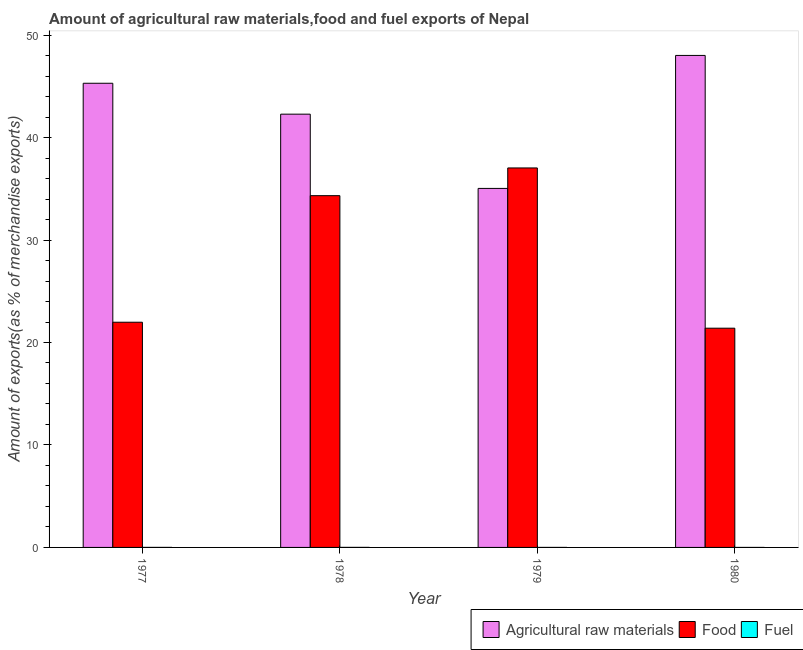How many groups of bars are there?
Your response must be concise. 4. Are the number of bars per tick equal to the number of legend labels?
Your answer should be compact. Yes. How many bars are there on the 3rd tick from the right?
Offer a terse response. 3. What is the label of the 2nd group of bars from the left?
Offer a very short reply. 1978. In how many cases, is the number of bars for a given year not equal to the number of legend labels?
Make the answer very short. 0. What is the percentage of food exports in 1977?
Offer a terse response. 21.98. Across all years, what is the maximum percentage of food exports?
Offer a very short reply. 37.03. Across all years, what is the minimum percentage of fuel exports?
Keep it short and to the point. 4.5184108995034e-5. In which year was the percentage of fuel exports maximum?
Provide a short and direct response. 1978. In which year was the percentage of raw materials exports minimum?
Keep it short and to the point. 1979. What is the total percentage of food exports in the graph?
Keep it short and to the point. 114.74. What is the difference between the percentage of food exports in 1977 and that in 1979?
Your answer should be very brief. -15.06. What is the difference between the percentage of fuel exports in 1978 and the percentage of raw materials exports in 1979?
Keep it short and to the point. 0. What is the average percentage of food exports per year?
Your answer should be compact. 28.68. In the year 1979, what is the difference between the percentage of food exports and percentage of fuel exports?
Give a very brief answer. 0. In how many years, is the percentage of raw materials exports greater than 16 %?
Keep it short and to the point. 4. What is the ratio of the percentage of fuel exports in 1977 to that in 1980?
Ensure brevity in your answer.  47.85. Is the percentage of food exports in 1977 less than that in 1979?
Provide a succinct answer. Yes. What is the difference between the highest and the second highest percentage of fuel exports?
Provide a succinct answer. 0. What is the difference between the highest and the lowest percentage of fuel exports?
Your answer should be very brief. 0. What does the 1st bar from the left in 1977 represents?
Your answer should be very brief. Agricultural raw materials. What does the 3rd bar from the right in 1979 represents?
Keep it short and to the point. Agricultural raw materials. How many bars are there?
Offer a very short reply. 12. Are the values on the major ticks of Y-axis written in scientific E-notation?
Offer a terse response. No. Where does the legend appear in the graph?
Your answer should be compact. Bottom right. What is the title of the graph?
Offer a terse response. Amount of agricultural raw materials,food and fuel exports of Nepal. What is the label or title of the Y-axis?
Your answer should be very brief. Amount of exports(as % of merchandise exports). What is the Amount of exports(as % of merchandise exports) of Agricultural raw materials in 1977?
Give a very brief answer. 45.3. What is the Amount of exports(as % of merchandise exports) in Food in 1977?
Your answer should be very brief. 21.98. What is the Amount of exports(as % of merchandise exports) in Fuel in 1977?
Provide a short and direct response. 0. What is the Amount of exports(as % of merchandise exports) of Agricultural raw materials in 1978?
Your answer should be very brief. 42.28. What is the Amount of exports(as % of merchandise exports) in Food in 1978?
Give a very brief answer. 34.33. What is the Amount of exports(as % of merchandise exports) in Fuel in 1978?
Your answer should be very brief. 0. What is the Amount of exports(as % of merchandise exports) in Agricultural raw materials in 1979?
Ensure brevity in your answer.  35.04. What is the Amount of exports(as % of merchandise exports) of Food in 1979?
Your answer should be compact. 37.03. What is the Amount of exports(as % of merchandise exports) of Fuel in 1979?
Give a very brief answer. 0. What is the Amount of exports(as % of merchandise exports) of Agricultural raw materials in 1980?
Make the answer very short. 48.02. What is the Amount of exports(as % of merchandise exports) of Food in 1980?
Offer a very short reply. 21.4. What is the Amount of exports(as % of merchandise exports) in Fuel in 1980?
Your response must be concise. 4.5184108995034e-5. Across all years, what is the maximum Amount of exports(as % of merchandise exports) of Agricultural raw materials?
Provide a succinct answer. 48.02. Across all years, what is the maximum Amount of exports(as % of merchandise exports) of Food?
Make the answer very short. 37.03. Across all years, what is the maximum Amount of exports(as % of merchandise exports) of Fuel?
Your answer should be very brief. 0. Across all years, what is the minimum Amount of exports(as % of merchandise exports) of Agricultural raw materials?
Provide a succinct answer. 35.04. Across all years, what is the minimum Amount of exports(as % of merchandise exports) in Food?
Provide a short and direct response. 21.4. Across all years, what is the minimum Amount of exports(as % of merchandise exports) of Fuel?
Give a very brief answer. 4.5184108995034e-5. What is the total Amount of exports(as % of merchandise exports) in Agricultural raw materials in the graph?
Your response must be concise. 170.64. What is the total Amount of exports(as % of merchandise exports) of Food in the graph?
Ensure brevity in your answer.  114.74. What is the total Amount of exports(as % of merchandise exports) of Fuel in the graph?
Provide a succinct answer. 0.01. What is the difference between the Amount of exports(as % of merchandise exports) in Agricultural raw materials in 1977 and that in 1978?
Your response must be concise. 3.02. What is the difference between the Amount of exports(as % of merchandise exports) in Food in 1977 and that in 1978?
Give a very brief answer. -12.35. What is the difference between the Amount of exports(as % of merchandise exports) in Fuel in 1977 and that in 1978?
Your answer should be very brief. -0. What is the difference between the Amount of exports(as % of merchandise exports) of Agricultural raw materials in 1977 and that in 1979?
Your response must be concise. 10.26. What is the difference between the Amount of exports(as % of merchandise exports) of Food in 1977 and that in 1979?
Make the answer very short. -15.06. What is the difference between the Amount of exports(as % of merchandise exports) in Fuel in 1977 and that in 1979?
Offer a terse response. 0. What is the difference between the Amount of exports(as % of merchandise exports) of Agricultural raw materials in 1977 and that in 1980?
Keep it short and to the point. -2.72. What is the difference between the Amount of exports(as % of merchandise exports) in Food in 1977 and that in 1980?
Ensure brevity in your answer.  0.58. What is the difference between the Amount of exports(as % of merchandise exports) in Fuel in 1977 and that in 1980?
Keep it short and to the point. 0. What is the difference between the Amount of exports(as % of merchandise exports) in Agricultural raw materials in 1978 and that in 1979?
Ensure brevity in your answer.  7.25. What is the difference between the Amount of exports(as % of merchandise exports) in Food in 1978 and that in 1979?
Give a very brief answer. -2.7. What is the difference between the Amount of exports(as % of merchandise exports) of Fuel in 1978 and that in 1979?
Offer a very short reply. 0. What is the difference between the Amount of exports(as % of merchandise exports) of Agricultural raw materials in 1978 and that in 1980?
Give a very brief answer. -5.73. What is the difference between the Amount of exports(as % of merchandise exports) in Food in 1978 and that in 1980?
Your response must be concise. 12.93. What is the difference between the Amount of exports(as % of merchandise exports) in Fuel in 1978 and that in 1980?
Provide a short and direct response. 0. What is the difference between the Amount of exports(as % of merchandise exports) in Agricultural raw materials in 1979 and that in 1980?
Offer a very short reply. -12.98. What is the difference between the Amount of exports(as % of merchandise exports) of Food in 1979 and that in 1980?
Ensure brevity in your answer.  15.64. What is the difference between the Amount of exports(as % of merchandise exports) in Fuel in 1979 and that in 1980?
Make the answer very short. 0. What is the difference between the Amount of exports(as % of merchandise exports) of Agricultural raw materials in 1977 and the Amount of exports(as % of merchandise exports) of Food in 1978?
Your answer should be compact. 10.97. What is the difference between the Amount of exports(as % of merchandise exports) of Agricultural raw materials in 1977 and the Amount of exports(as % of merchandise exports) of Fuel in 1978?
Give a very brief answer. 45.3. What is the difference between the Amount of exports(as % of merchandise exports) of Food in 1977 and the Amount of exports(as % of merchandise exports) of Fuel in 1978?
Your answer should be very brief. 21.97. What is the difference between the Amount of exports(as % of merchandise exports) of Agricultural raw materials in 1977 and the Amount of exports(as % of merchandise exports) of Food in 1979?
Offer a very short reply. 8.26. What is the difference between the Amount of exports(as % of merchandise exports) of Agricultural raw materials in 1977 and the Amount of exports(as % of merchandise exports) of Fuel in 1979?
Your answer should be very brief. 45.3. What is the difference between the Amount of exports(as % of merchandise exports) of Food in 1977 and the Amount of exports(as % of merchandise exports) of Fuel in 1979?
Ensure brevity in your answer.  21.98. What is the difference between the Amount of exports(as % of merchandise exports) of Agricultural raw materials in 1977 and the Amount of exports(as % of merchandise exports) of Food in 1980?
Offer a very short reply. 23.9. What is the difference between the Amount of exports(as % of merchandise exports) in Agricultural raw materials in 1977 and the Amount of exports(as % of merchandise exports) in Fuel in 1980?
Offer a terse response. 45.3. What is the difference between the Amount of exports(as % of merchandise exports) of Food in 1977 and the Amount of exports(as % of merchandise exports) of Fuel in 1980?
Ensure brevity in your answer.  21.98. What is the difference between the Amount of exports(as % of merchandise exports) of Agricultural raw materials in 1978 and the Amount of exports(as % of merchandise exports) of Food in 1979?
Give a very brief answer. 5.25. What is the difference between the Amount of exports(as % of merchandise exports) in Agricultural raw materials in 1978 and the Amount of exports(as % of merchandise exports) in Fuel in 1979?
Your answer should be very brief. 42.28. What is the difference between the Amount of exports(as % of merchandise exports) in Food in 1978 and the Amount of exports(as % of merchandise exports) in Fuel in 1979?
Your response must be concise. 34.33. What is the difference between the Amount of exports(as % of merchandise exports) in Agricultural raw materials in 1978 and the Amount of exports(as % of merchandise exports) in Food in 1980?
Your answer should be compact. 20.89. What is the difference between the Amount of exports(as % of merchandise exports) of Agricultural raw materials in 1978 and the Amount of exports(as % of merchandise exports) of Fuel in 1980?
Provide a short and direct response. 42.28. What is the difference between the Amount of exports(as % of merchandise exports) in Food in 1978 and the Amount of exports(as % of merchandise exports) in Fuel in 1980?
Your response must be concise. 34.33. What is the difference between the Amount of exports(as % of merchandise exports) of Agricultural raw materials in 1979 and the Amount of exports(as % of merchandise exports) of Food in 1980?
Your response must be concise. 13.64. What is the difference between the Amount of exports(as % of merchandise exports) of Agricultural raw materials in 1979 and the Amount of exports(as % of merchandise exports) of Fuel in 1980?
Your answer should be compact. 35.04. What is the difference between the Amount of exports(as % of merchandise exports) in Food in 1979 and the Amount of exports(as % of merchandise exports) in Fuel in 1980?
Your answer should be very brief. 37.03. What is the average Amount of exports(as % of merchandise exports) in Agricultural raw materials per year?
Provide a succinct answer. 42.66. What is the average Amount of exports(as % of merchandise exports) of Food per year?
Your answer should be compact. 28.68. What is the average Amount of exports(as % of merchandise exports) in Fuel per year?
Your response must be concise. 0. In the year 1977, what is the difference between the Amount of exports(as % of merchandise exports) in Agricultural raw materials and Amount of exports(as % of merchandise exports) in Food?
Your answer should be compact. 23.32. In the year 1977, what is the difference between the Amount of exports(as % of merchandise exports) of Agricultural raw materials and Amount of exports(as % of merchandise exports) of Fuel?
Your response must be concise. 45.3. In the year 1977, what is the difference between the Amount of exports(as % of merchandise exports) of Food and Amount of exports(as % of merchandise exports) of Fuel?
Your answer should be compact. 21.98. In the year 1978, what is the difference between the Amount of exports(as % of merchandise exports) of Agricultural raw materials and Amount of exports(as % of merchandise exports) of Food?
Keep it short and to the point. 7.95. In the year 1978, what is the difference between the Amount of exports(as % of merchandise exports) in Agricultural raw materials and Amount of exports(as % of merchandise exports) in Fuel?
Your answer should be compact. 42.28. In the year 1978, what is the difference between the Amount of exports(as % of merchandise exports) in Food and Amount of exports(as % of merchandise exports) in Fuel?
Offer a terse response. 34.33. In the year 1979, what is the difference between the Amount of exports(as % of merchandise exports) in Agricultural raw materials and Amount of exports(as % of merchandise exports) in Food?
Keep it short and to the point. -2. In the year 1979, what is the difference between the Amount of exports(as % of merchandise exports) of Agricultural raw materials and Amount of exports(as % of merchandise exports) of Fuel?
Ensure brevity in your answer.  35.04. In the year 1979, what is the difference between the Amount of exports(as % of merchandise exports) in Food and Amount of exports(as % of merchandise exports) in Fuel?
Your response must be concise. 37.03. In the year 1980, what is the difference between the Amount of exports(as % of merchandise exports) of Agricultural raw materials and Amount of exports(as % of merchandise exports) of Food?
Provide a short and direct response. 26.62. In the year 1980, what is the difference between the Amount of exports(as % of merchandise exports) of Agricultural raw materials and Amount of exports(as % of merchandise exports) of Fuel?
Your answer should be very brief. 48.02. In the year 1980, what is the difference between the Amount of exports(as % of merchandise exports) in Food and Amount of exports(as % of merchandise exports) in Fuel?
Your answer should be compact. 21.4. What is the ratio of the Amount of exports(as % of merchandise exports) in Agricultural raw materials in 1977 to that in 1978?
Offer a terse response. 1.07. What is the ratio of the Amount of exports(as % of merchandise exports) in Food in 1977 to that in 1978?
Ensure brevity in your answer.  0.64. What is the ratio of the Amount of exports(as % of merchandise exports) in Fuel in 1977 to that in 1978?
Provide a short and direct response. 0.6. What is the ratio of the Amount of exports(as % of merchandise exports) of Agricultural raw materials in 1977 to that in 1979?
Make the answer very short. 1.29. What is the ratio of the Amount of exports(as % of merchandise exports) of Food in 1977 to that in 1979?
Keep it short and to the point. 0.59. What is the ratio of the Amount of exports(as % of merchandise exports) in Fuel in 1977 to that in 1979?
Ensure brevity in your answer.  1.28. What is the ratio of the Amount of exports(as % of merchandise exports) of Agricultural raw materials in 1977 to that in 1980?
Provide a succinct answer. 0.94. What is the ratio of the Amount of exports(as % of merchandise exports) of Food in 1977 to that in 1980?
Your answer should be very brief. 1.03. What is the ratio of the Amount of exports(as % of merchandise exports) in Fuel in 1977 to that in 1980?
Your response must be concise. 47.85. What is the ratio of the Amount of exports(as % of merchandise exports) in Agricultural raw materials in 1978 to that in 1979?
Provide a short and direct response. 1.21. What is the ratio of the Amount of exports(as % of merchandise exports) of Food in 1978 to that in 1979?
Offer a terse response. 0.93. What is the ratio of the Amount of exports(as % of merchandise exports) of Fuel in 1978 to that in 1979?
Give a very brief answer. 2.12. What is the ratio of the Amount of exports(as % of merchandise exports) in Agricultural raw materials in 1978 to that in 1980?
Your answer should be compact. 0.88. What is the ratio of the Amount of exports(as % of merchandise exports) of Food in 1978 to that in 1980?
Your answer should be very brief. 1.6. What is the ratio of the Amount of exports(as % of merchandise exports) of Fuel in 1978 to that in 1980?
Offer a very short reply. 79.14. What is the ratio of the Amount of exports(as % of merchandise exports) in Agricultural raw materials in 1979 to that in 1980?
Ensure brevity in your answer.  0.73. What is the ratio of the Amount of exports(as % of merchandise exports) of Food in 1979 to that in 1980?
Your answer should be very brief. 1.73. What is the ratio of the Amount of exports(as % of merchandise exports) in Fuel in 1979 to that in 1980?
Provide a short and direct response. 37.35. What is the difference between the highest and the second highest Amount of exports(as % of merchandise exports) in Agricultural raw materials?
Offer a very short reply. 2.72. What is the difference between the highest and the second highest Amount of exports(as % of merchandise exports) of Food?
Your response must be concise. 2.7. What is the difference between the highest and the second highest Amount of exports(as % of merchandise exports) in Fuel?
Give a very brief answer. 0. What is the difference between the highest and the lowest Amount of exports(as % of merchandise exports) of Agricultural raw materials?
Offer a very short reply. 12.98. What is the difference between the highest and the lowest Amount of exports(as % of merchandise exports) of Food?
Your response must be concise. 15.64. What is the difference between the highest and the lowest Amount of exports(as % of merchandise exports) in Fuel?
Provide a succinct answer. 0. 